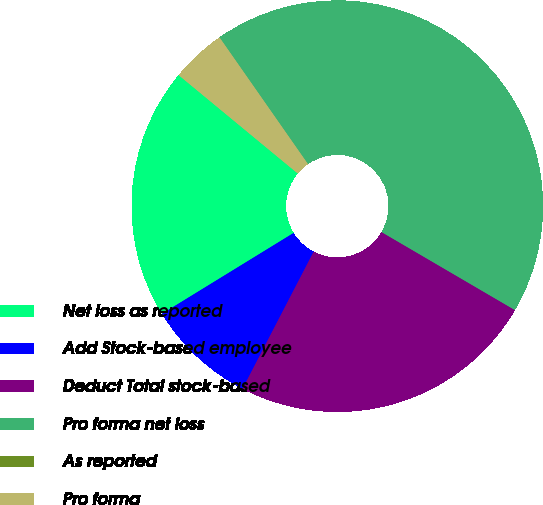Convert chart. <chart><loc_0><loc_0><loc_500><loc_500><pie_chart><fcel>Net loss as reported<fcel>Add Stock-based employee<fcel>Deduct Total stock-based<fcel>Pro forma net loss<fcel>As reported<fcel>Pro forma<nl><fcel>19.75%<fcel>8.62%<fcel>24.19%<fcel>43.12%<fcel>0.0%<fcel>4.31%<nl></chart> 